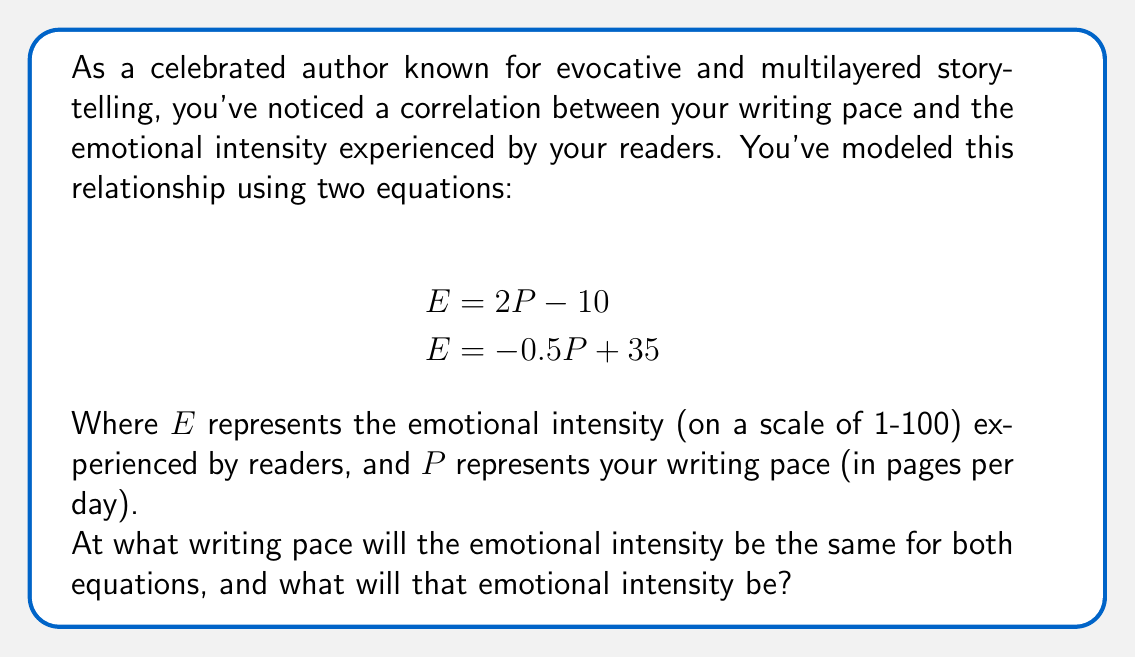Help me with this question. To solve this problem, we need to find the point of intersection between the two equations. This is where the emotional intensity will be the same for both equations.

Let's solve this step-by-step:

1) We have two equations:
   $$E = 2P - 10$$ (Equation 1)
   $$E = -0.5P + 35$$ (Equation 2)

2) At the point of intersection, the $E$ values will be equal. So we can set the right sides of the equations equal to each other:

   $$2P - 10 = -0.5P + 35$$

3) Now, let's solve this equation for $P$:
   
   $$2P + 0.5P = 35 + 10$$
   $$2.5P = 45$$
   $$P = 45 / 2.5 = 18$$

4) So, the writing pace at the point of intersection is 18 pages per day.

5) To find the emotional intensity at this point, we can plug $P = 18$ into either of our original equations. Let's use Equation 1:

   $$E = 2P - 10$$
   $$E = 2(18) - 10$$
   $$E = 36 - 10 = 26$$

Therefore, at a writing pace of 18 pages per day, both equations yield an emotional intensity of 26.
Answer: The writing pace will be 18 pages per day, and the emotional intensity will be 26. 